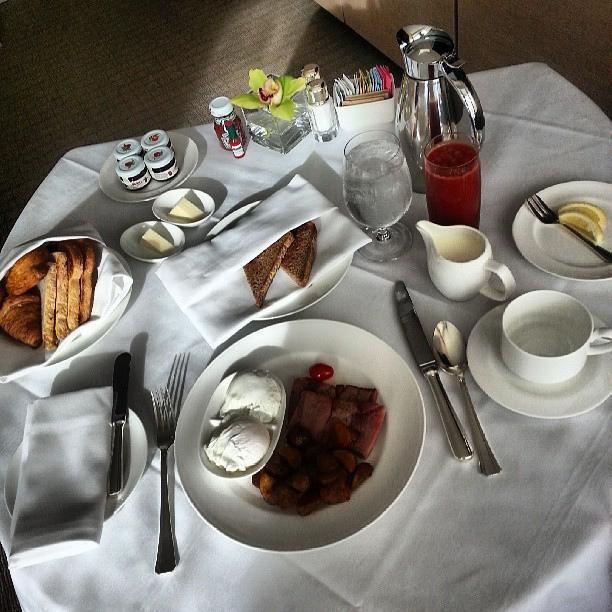How many place settings?
Give a very brief answer. 1. How many cups are in the picture?
Give a very brief answer. 3. How many bowls are visible?
Give a very brief answer. 2. How many people are wearing a red hat?
Give a very brief answer. 0. 